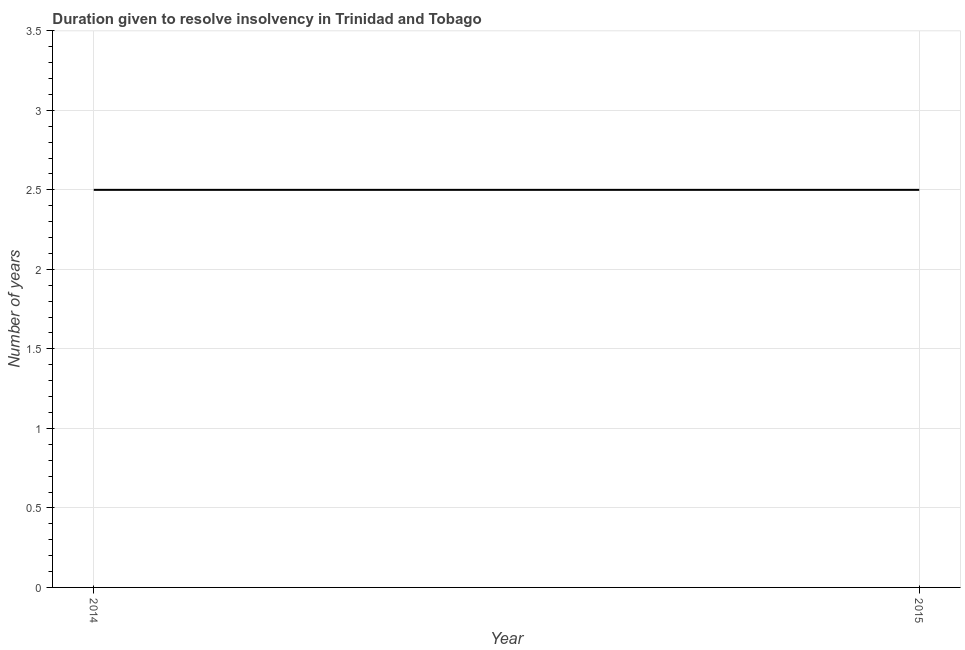Across all years, what is the maximum number of years to resolve insolvency?
Keep it short and to the point. 2.5. What is the sum of the number of years to resolve insolvency?
Make the answer very short. 5. What is the average number of years to resolve insolvency per year?
Ensure brevity in your answer.  2.5. In how many years, is the number of years to resolve insolvency greater than 0.5 ?
Provide a succinct answer. 2. In how many years, is the number of years to resolve insolvency greater than the average number of years to resolve insolvency taken over all years?
Provide a short and direct response. 0. Does the number of years to resolve insolvency monotonically increase over the years?
Provide a succinct answer. No. Does the graph contain any zero values?
Offer a terse response. No. What is the title of the graph?
Provide a succinct answer. Duration given to resolve insolvency in Trinidad and Tobago. What is the label or title of the X-axis?
Your answer should be compact. Year. What is the label or title of the Y-axis?
Give a very brief answer. Number of years. What is the Number of years of 2014?
Ensure brevity in your answer.  2.5. 